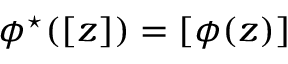Convert formula to latex. <formula><loc_0><loc_0><loc_500><loc_500>\phi ^ { ^ { * } } ( [ z ] ) = [ \phi ( z ) ]</formula> 